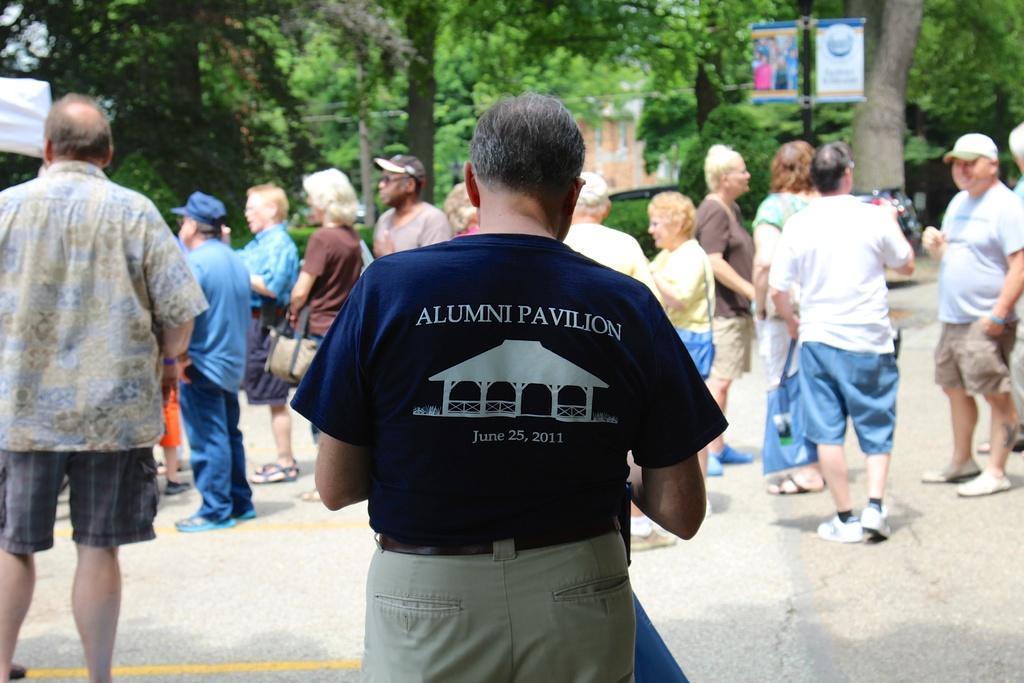Can you describe this image briefly? In this picture we can observe some people standing. There is a person wearing a blue color T shirt. There are men and women in this picture. In the background there are trees. We can observe two posters here. 